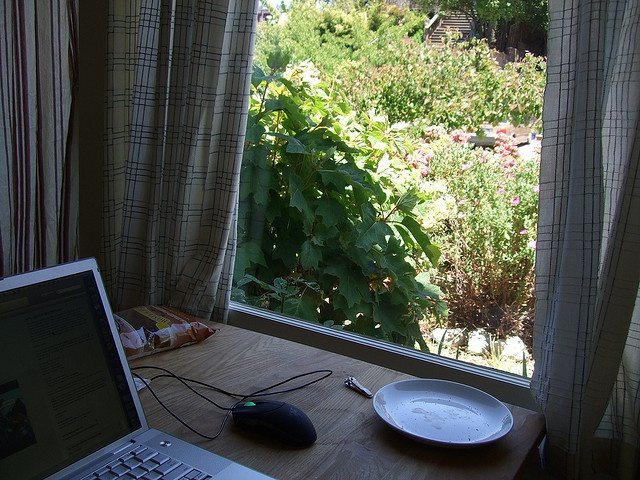Describe the objects in this image and their specific colors. I can see laptop in gray, black, and blue tones and mouse in gray, black, navy, and teal tones in this image. 